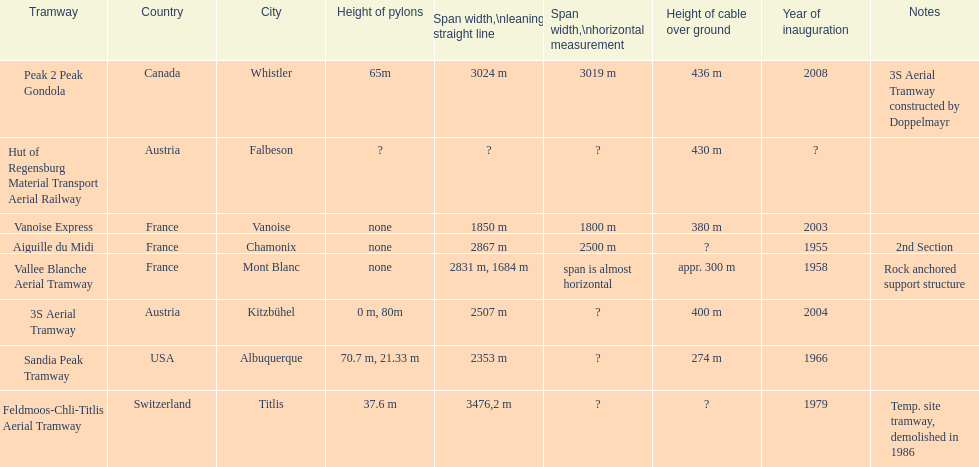Which tramway was inaugurated first, the 3s aerial tramway or the aiguille du midi? Aiguille du Midi. 